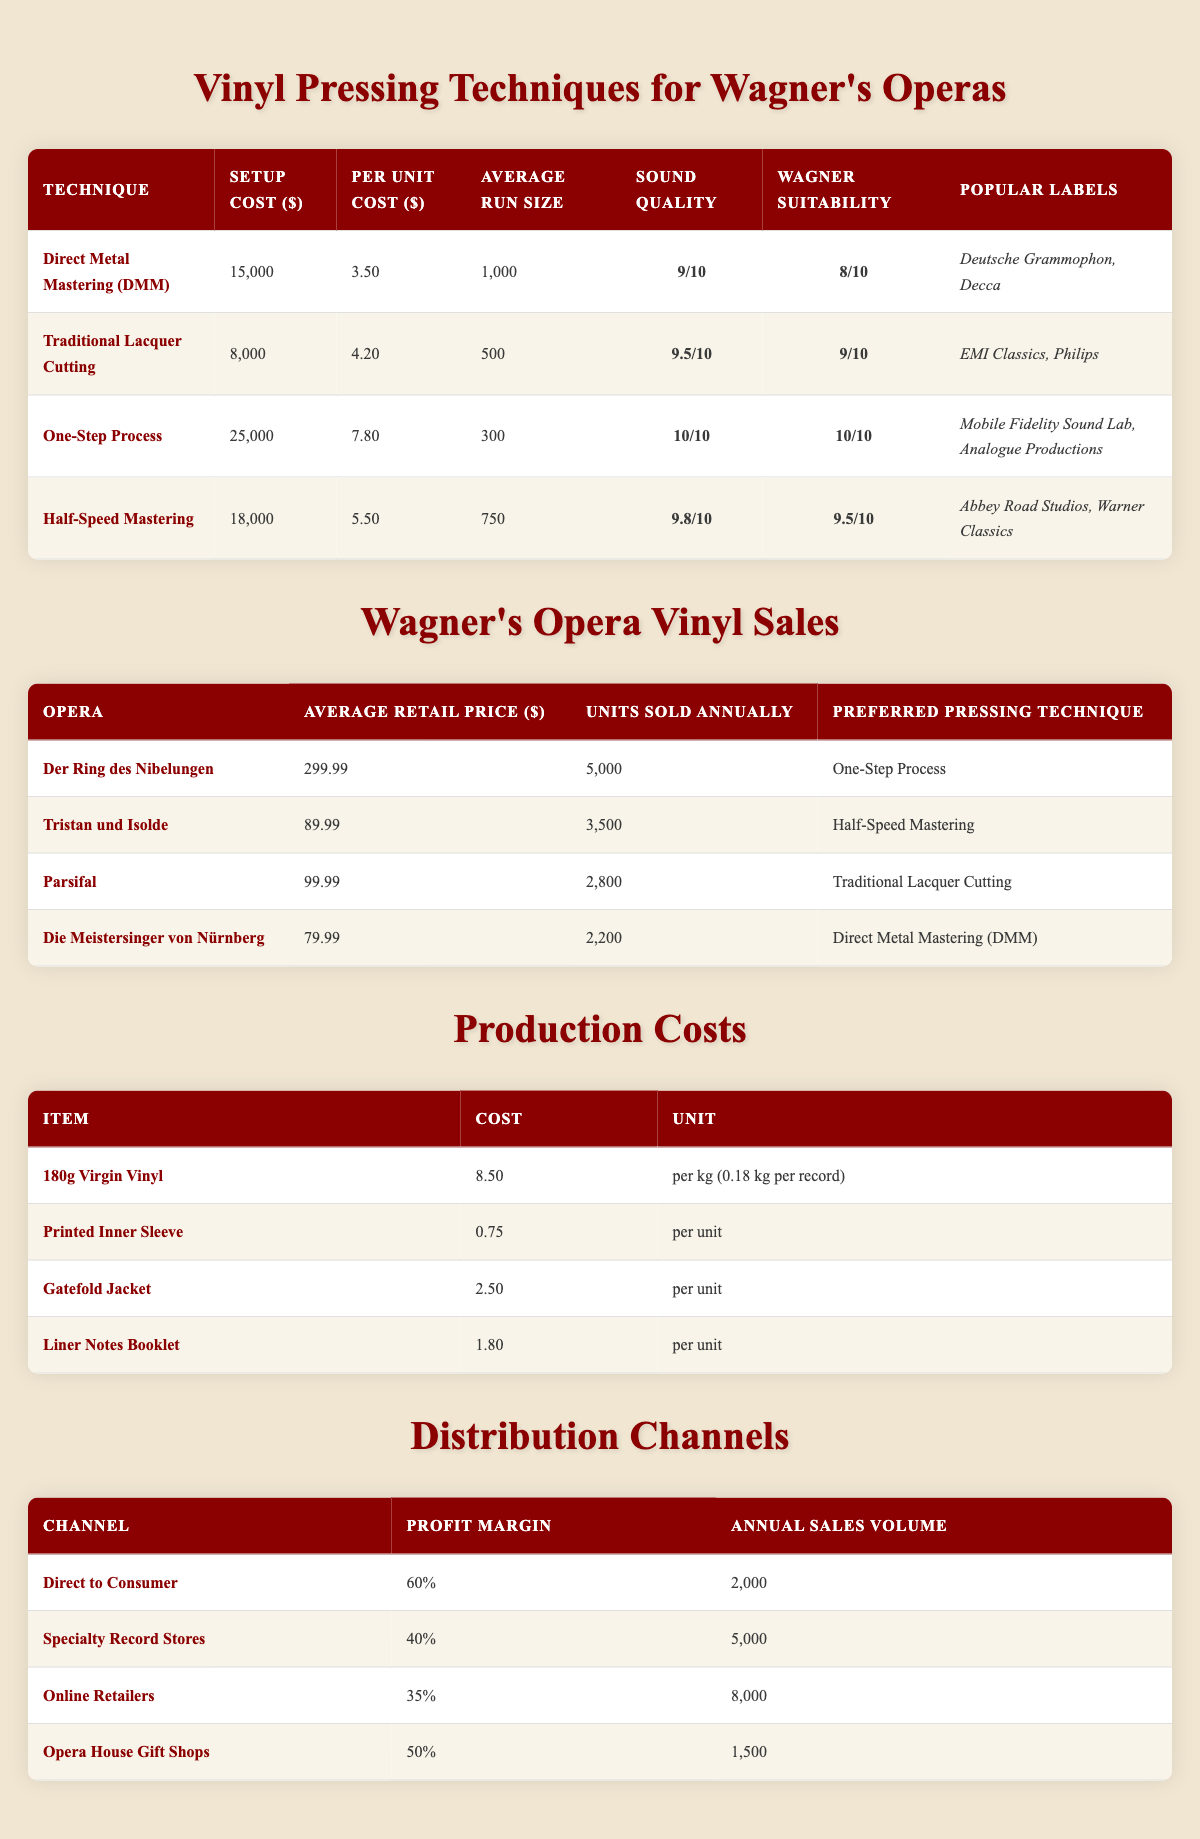What is the average retail price of "Tristan und Isolde"? The table provides the average retail price for each Wagner opera. Specifically for "Tristan und Isolde," it lists the average retail price as 89.99.
Answer: 89.99 Which pressing technique has the highest sound quality rating? From the vinyl pressing techniques table, the "One-Step Process" has the highest sound quality rating of 10 out of 10.
Answer: One-Step Process Is "Die Meistersinger von Nürnberg" typically pressed using the One-Step Process? According to the table detailing Wagner's opera vinyl sales, "Die Meistersinger von Nürnberg" uses Direct Metal Mastering (DMM) as its preferred pressing technique, not One-Step Process.
Answer: No What is the total production cost per unit for a record using the Half-Speed Mastering technique? First, we identify the pressing technique, which has a per unit cost of 5.50. Then we need to calculate the production costs: 0.18 kg of vinyl at 8.50 per kg, plus 0.75 for the printed inner sleeve, 2.50 for the gatefold jacket, and 1.80 for the liner notes booklet. The computation is 5.50 + (0.18 * 8.50) + 0.75 + 2.50 + 1.80 = 5.50 + 1.53 + 0.75 + 2.50 + 1.80 = 12.08.
Answer: 12.08 Which vinyl pressing technique is preferred for "Der Ring des Nibelungen"? The data on Wagner's opera vinyl sales indicates that the preferred pressing technique for "Der Ring des Nibelungen" is the One-Step Process.
Answer: One-Step Process What is the overall profit margin for sales through Online Retailers? The profit margin listed for Online Retailers in the distribution channels table is 35 percent.
Answer: 35% What is the average setup cost of all the pressing techniques? To find the average setup cost, we add the setup costs for each technique: 15000 + 8000 + 25000 + 18000 = 66500. Then, divide by the number of techniques, which is 4: 66500 / 4 = 16625.
Answer: 16625 